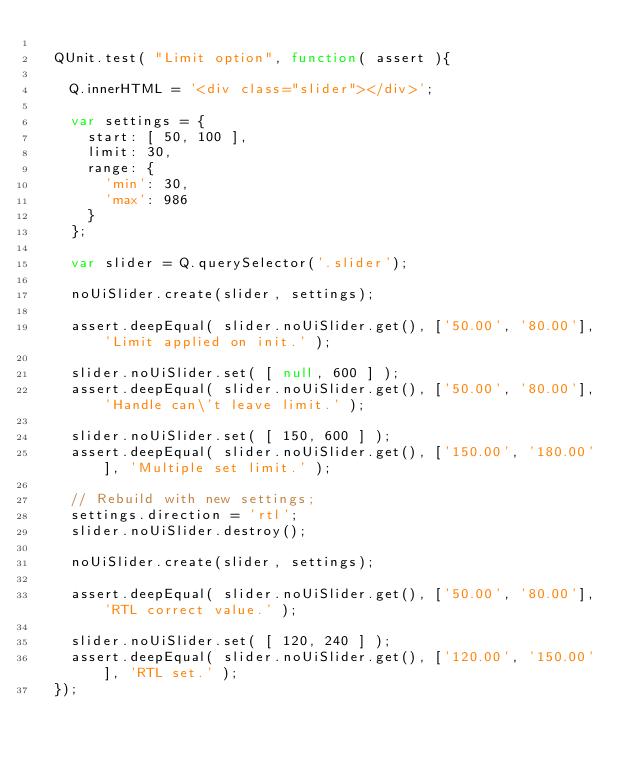Convert code to text. <code><loc_0><loc_0><loc_500><loc_500><_JavaScript_>
	QUnit.test( "Limit option", function( assert ){

		Q.innerHTML = '<div class="slider"></div>';

		var settings = {
			start: [ 50, 100 ],
			limit: 30,
			range: {
				'min': 30,
				'max': 986
			}
		};

		var slider = Q.querySelector('.slider');

		noUiSlider.create(slider, settings);

		assert.deepEqual( slider.noUiSlider.get(), ['50.00', '80.00'], 'Limit applied on init.' );

		slider.noUiSlider.set( [ null, 600 ] );
		assert.deepEqual( slider.noUiSlider.get(), ['50.00', '80.00'], 'Handle can\'t leave limit.' );

		slider.noUiSlider.set( [ 150, 600 ] );
		assert.deepEqual( slider.noUiSlider.get(), ['150.00', '180.00'], 'Multiple set limit.' );

		// Rebuild with new settings;
		settings.direction = 'rtl';
		slider.noUiSlider.destroy();

		noUiSlider.create(slider, settings);

		assert.deepEqual( slider.noUiSlider.get(), ['50.00', '80.00'], 'RTL correct value.' );

		slider.noUiSlider.set( [ 120, 240 ] );
		assert.deepEqual( slider.noUiSlider.get(), ['120.00', '150.00'], 'RTL set.' );
	});
</code> 